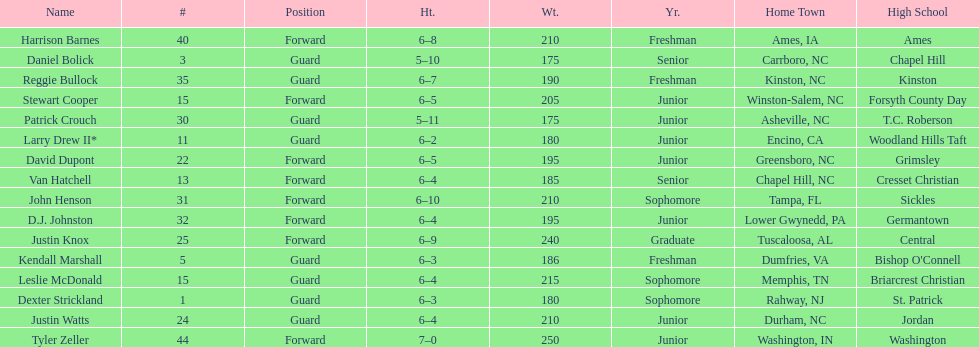How many players are not a junior? 9. Give me the full table as a dictionary. {'header': ['Name', '#', 'Position', 'Ht.', 'Wt.', 'Yr.', 'Home Town', 'High School'], 'rows': [['Harrison Barnes', '40', 'Forward', '6–8', '210', 'Freshman', 'Ames, IA', 'Ames'], ['Daniel Bolick', '3', 'Guard', '5–10', '175', 'Senior', 'Carrboro, NC', 'Chapel Hill'], ['Reggie Bullock', '35', 'Guard', '6–7', '190', 'Freshman', 'Kinston, NC', 'Kinston'], ['Stewart Cooper', '15', 'Forward', '6–5', '205', 'Junior', 'Winston-Salem, NC', 'Forsyth County Day'], ['Patrick Crouch', '30', 'Guard', '5–11', '175', 'Junior', 'Asheville, NC', 'T.C. Roberson'], ['Larry Drew II*', '11', 'Guard', '6–2', '180', 'Junior', 'Encino, CA', 'Woodland Hills Taft'], ['David Dupont', '22', 'Forward', '6–5', '195', 'Junior', 'Greensboro, NC', 'Grimsley'], ['Van Hatchell', '13', 'Forward', '6–4', '185', 'Senior', 'Chapel Hill, NC', 'Cresset Christian'], ['John Henson', '31', 'Forward', '6–10', '210', 'Sophomore', 'Tampa, FL', 'Sickles'], ['D.J. Johnston', '32', 'Forward', '6–4', '195', 'Junior', 'Lower Gwynedd, PA', 'Germantown'], ['Justin Knox', '25', 'Forward', '6–9', '240', 'Graduate', 'Tuscaloosa, AL', 'Central'], ['Kendall Marshall', '5', 'Guard', '6–3', '186', 'Freshman', 'Dumfries, VA', "Bishop O'Connell"], ['Leslie McDonald', '15', 'Guard', '6–4', '215', 'Sophomore', 'Memphis, TN', 'Briarcrest Christian'], ['Dexter Strickland', '1', 'Guard', '6–3', '180', 'Sophomore', 'Rahway, NJ', 'St. Patrick'], ['Justin Watts', '24', 'Guard', '6–4', '210', 'Junior', 'Durham, NC', 'Jordan'], ['Tyler Zeller', '44', 'Forward', '7–0', '250', 'Junior', 'Washington, IN', 'Washington']]} 